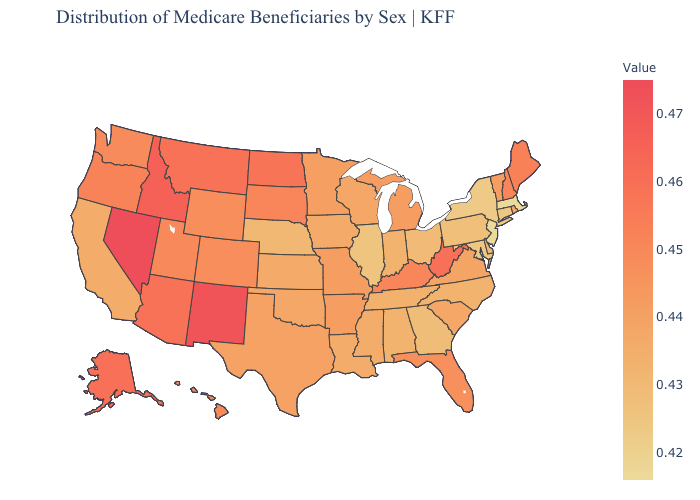Among the states that border North Dakota , which have the highest value?
Answer briefly. Montana. Which states have the lowest value in the USA?
Write a very short answer. Massachusetts, New Jersey. Among the states that border Vermont , does Massachusetts have the highest value?
Quick response, please. No. Does Oregon have a higher value than Tennessee?
Keep it brief. Yes. 